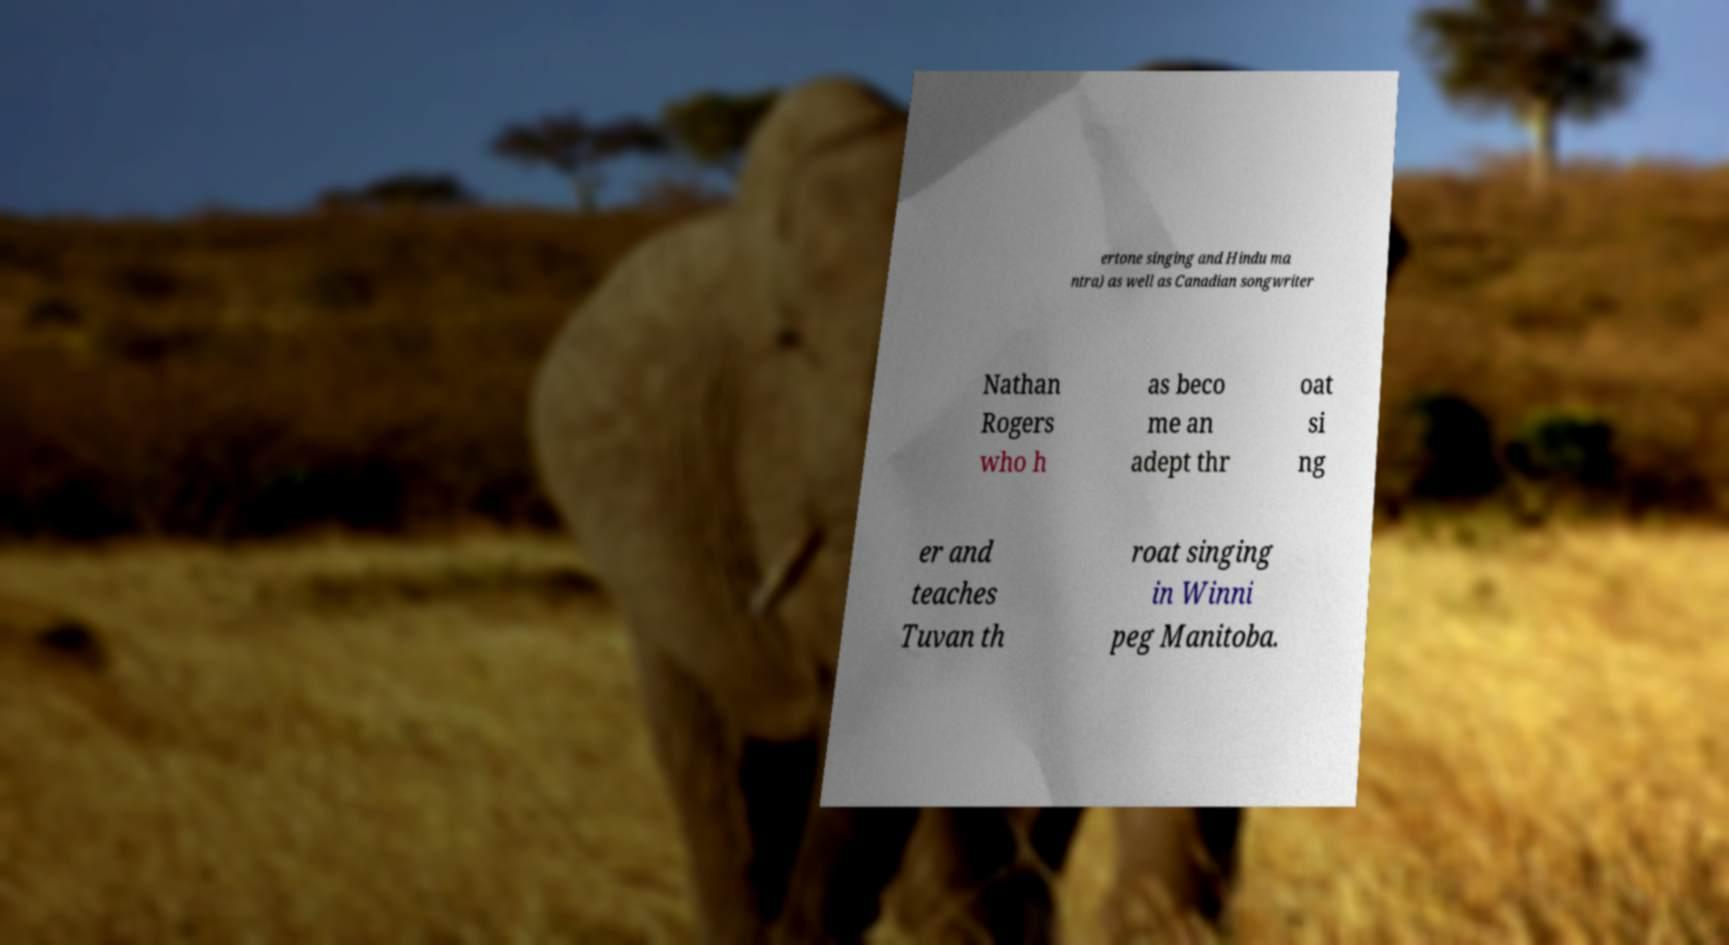I need the written content from this picture converted into text. Can you do that? ertone singing and Hindu ma ntra) as well as Canadian songwriter Nathan Rogers who h as beco me an adept thr oat si ng er and teaches Tuvan th roat singing in Winni peg Manitoba. 